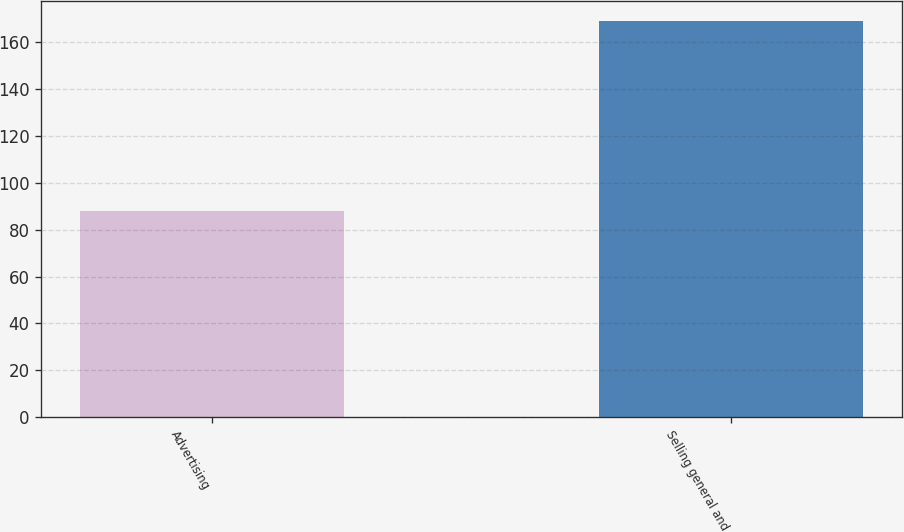<chart> <loc_0><loc_0><loc_500><loc_500><bar_chart><fcel>Advertising<fcel>Selling general and<nl><fcel>88<fcel>169<nl></chart> 